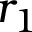<formula> <loc_0><loc_0><loc_500><loc_500>r _ { 1 }</formula> 